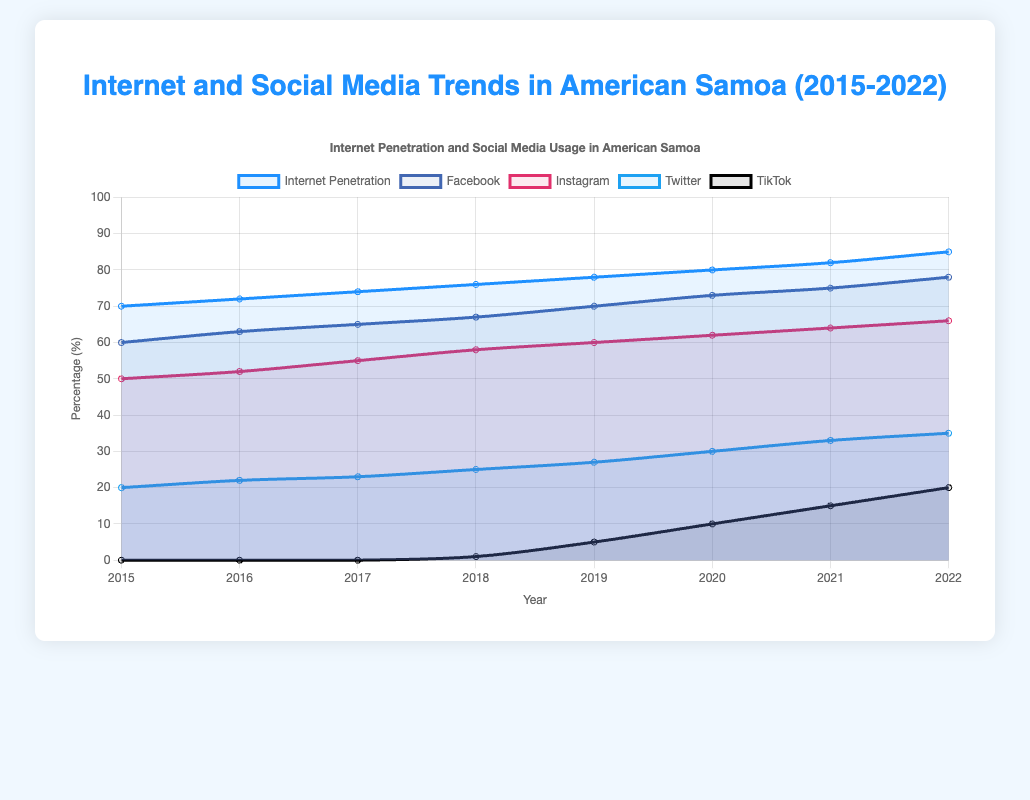What is the trend of Internet penetration from 2015 to 2022? From 2015 to 2022, the percentage of Internet penetration increases consistently every year. Starting at 70% in 2015 and reaching 85% in 2022.
Answer: Increasing Which year experienced the highest increase in TikTok usage? TikTok usage saw the most significant jump between 2019 and 2020, increasing from 1% to 5%. This is a 4% increase in a single year.
Answer: 2020 How do Facebook and Instagram usage compare in 2022? In 2022, Facebook usage is at 78%, whereas Instagram is at 66%. Facebook has higher usage compared to Instagram in 2022.
Answer: Facebook > Instagram What is the difference in usage percentage between Twitter and TikTok in 2022? In 2022, Twitter usage is at 35% and TikTok is at 20%. The difference between them is 35% - 20% = 15%.
Answer: 15% What social media platform showed the most dramatic increase in usage from 2018 to 2022? From 2018 to 2022, TikTok's usage increased from 1% to 20%, which is a 19% rise—the most dramatic increase among the platforms.
Answer: TikTok What was the total increase in internet penetration percentage from 2015 to 2022? The Internet penetration percentage increased from 70% in 2015 to 85% in 2022. The total increase is 85% - 70% = 15%.
Answer: 15% In which year did Instagram usage surpass 60%? Instagram usage surpassed 60% in 2019, reaching exactly 60% that year.
Answer: 2019 How does the trend of Twitter usage from 2015 to 2022 compare with TikTok's trend? Twitter usage shows a steady increase from 20% in 2015 to 35% in 2022. Meanwhile, TikTok started at 0% in 2015 and rapidly climbed to 20% by 2022. Both trends are upwards, but TikTok's growth is more rapid and noticeable in the later years.
Answer: Both increasing, TikTok more rapid How does the color used for Internet penetration in the plot visually distinguish it from social media usage lines? The line for Internet penetration is represented in a shade of blue, distinct from the other colors used for social media platforms, making it visually identifiable and easier to follow.
Answer: Shade of blue 